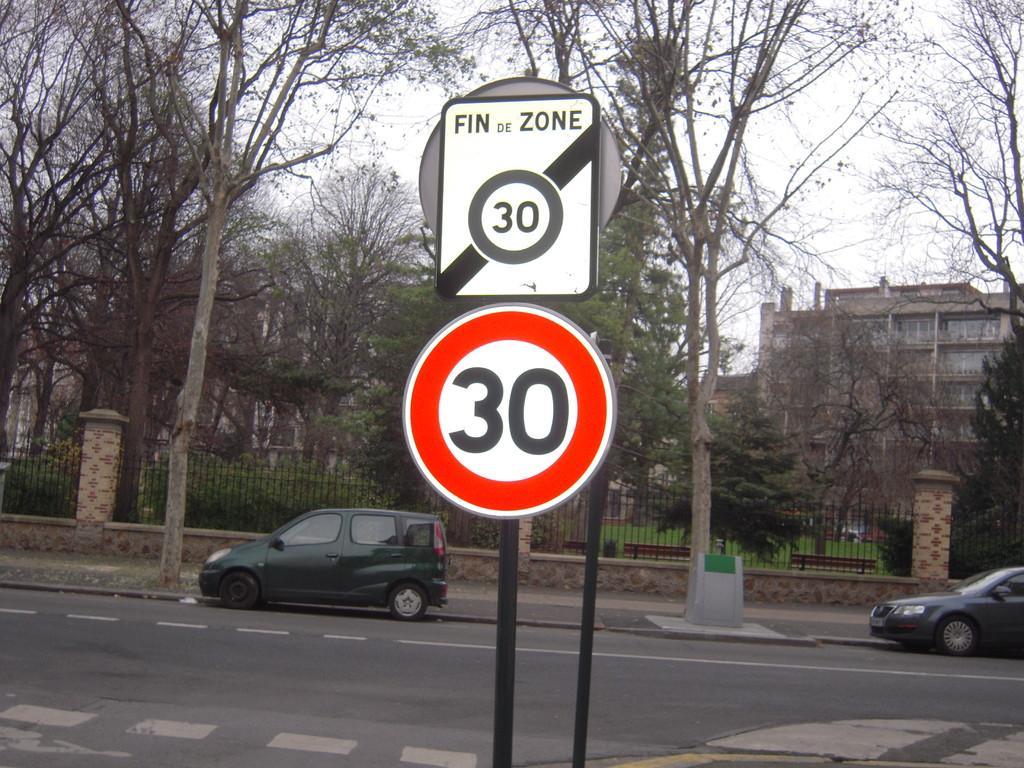How would you summarize this image in a sentence or two? In the image there is a sign board in the middle, behind it there are two cars going on road followed by fence behind it and trees all over the place, on the right side background there is a building and above its sky. 